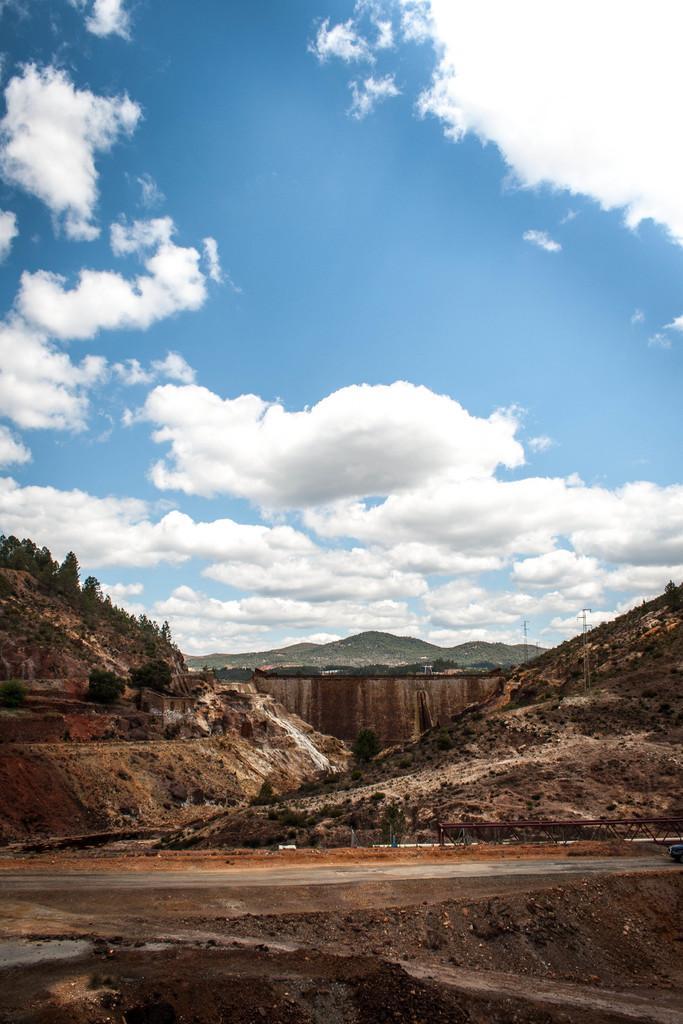Could you give a brief overview of what you see in this image? In this image we can see group of mountains, poles, trees and the cloudy sky. 